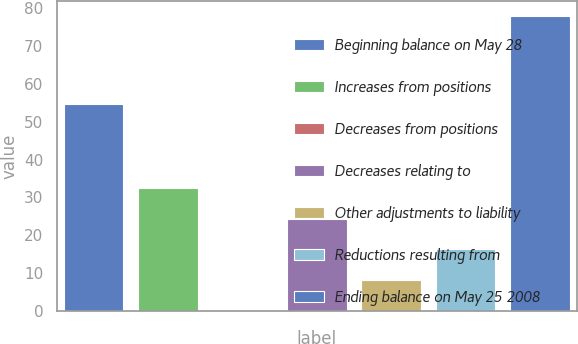Convert chart. <chart><loc_0><loc_0><loc_500><loc_500><bar_chart><fcel>Beginning balance on May 28<fcel>Increases from positions<fcel>Decreases from positions<fcel>Decreases relating to<fcel>Other adjustments to liability<fcel>Reductions resulting from<fcel>Ending balance on May 25 2008<nl><fcel>54.8<fcel>32.44<fcel>0.2<fcel>24.38<fcel>8.26<fcel>16.32<fcel>77.96<nl></chart> 